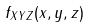<formula> <loc_0><loc_0><loc_500><loc_500>f _ { X Y Z } ( x , y , z )</formula> 